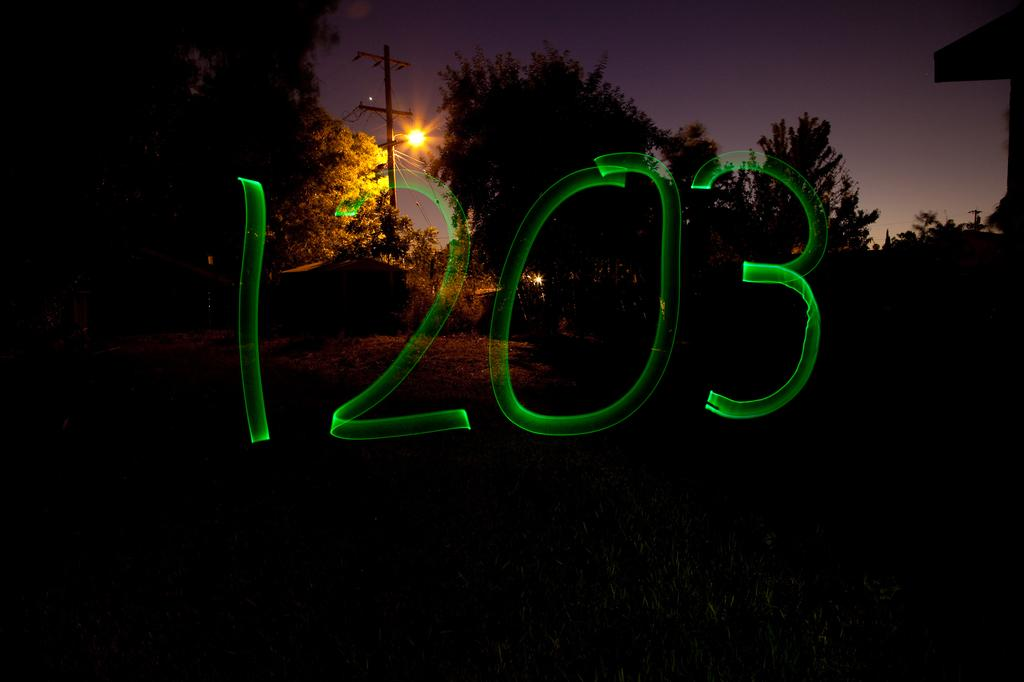What type of vegetation can be seen in the image? There are trees in the image. What is attached to the pole in the image? There is a light attached to the pole in the image. What structure is located on the right side of the image? There appears to be a building on the right side of the image. What can be found in the middle of the image? There is text in the middle of the image. Where is the vase located in the image? There is no vase present in the image. What type of apparatus is used to measure the height of the trees in the image? There is no apparatus present in the image for measuring the height of the trees. 